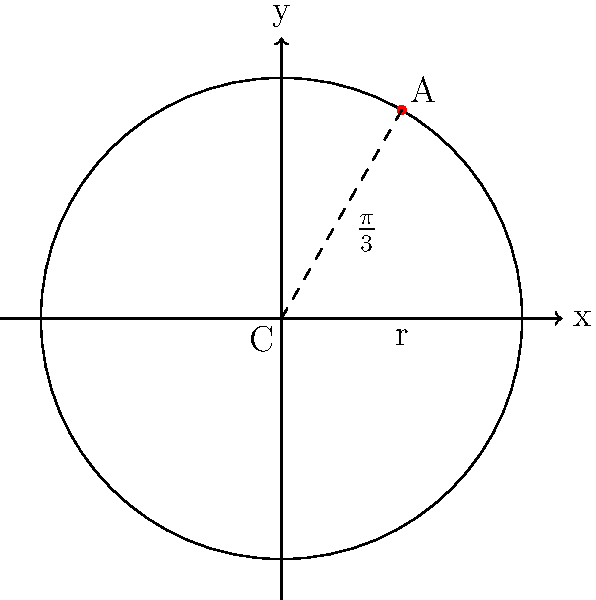In a circular pitch diagram representing musical notes, point A corresponds to the note G#. If the circle has a radius of 3 units and is centered at the origin, what are the coordinates of point A? Express your answer in terms of $\pi$. To find the coordinates of point A, we can follow these steps:

1) In a circular pitch diagram, the circle is divided into 12 equal parts, each representing a semitone. G# is the 8th semitone from C (which is typically at 0 degrees).

2) The angle for G# from the positive x-axis is:
   $\theta = \frac{8}{12} \cdot 2\pi = \frac{2\pi}{3}$

3) However, in the given diagram, we can see that the angle is $\frac{\pi}{3}$, which is half of $\frac{2\pi}{3}$. This means the diagram is showing the angle from the positive x-axis to G# in the opposite direction (clockwise instead of counterclockwise).

4) The coordinates of a point on a circle can be found using the parametric equations:
   $x = r \cos(\theta)$
   $y = r \sin(\theta)$

5) Substituting $r = 3$ and $\theta = \frac{\pi}{3}$:
   $x = 3 \cos(\frac{\pi}{3}) = 3 \cdot \frac{1}{2} = \frac{3}{2}$
   $y = 3 \sin(\frac{\pi}{3}) = 3 \cdot \frac{\sqrt{3}}{2} = \frac{3\sqrt{3}}{2}$

Therefore, the coordinates of point A are $(\frac{3}{2}, \frac{3\sqrt{3}}{2})$.
Answer: $(\frac{3}{2}, \frac{3\sqrt{3}}{2})$ 